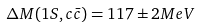Convert formula to latex. <formula><loc_0><loc_0><loc_500><loc_500>\Delta M ( 1 S , c \bar { c } ) = 1 1 7 \pm 2 M e V</formula> 